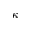Convert formula to latex. <formula><loc_0><loc_0><loc_500><loc_500>\kappa</formula> 